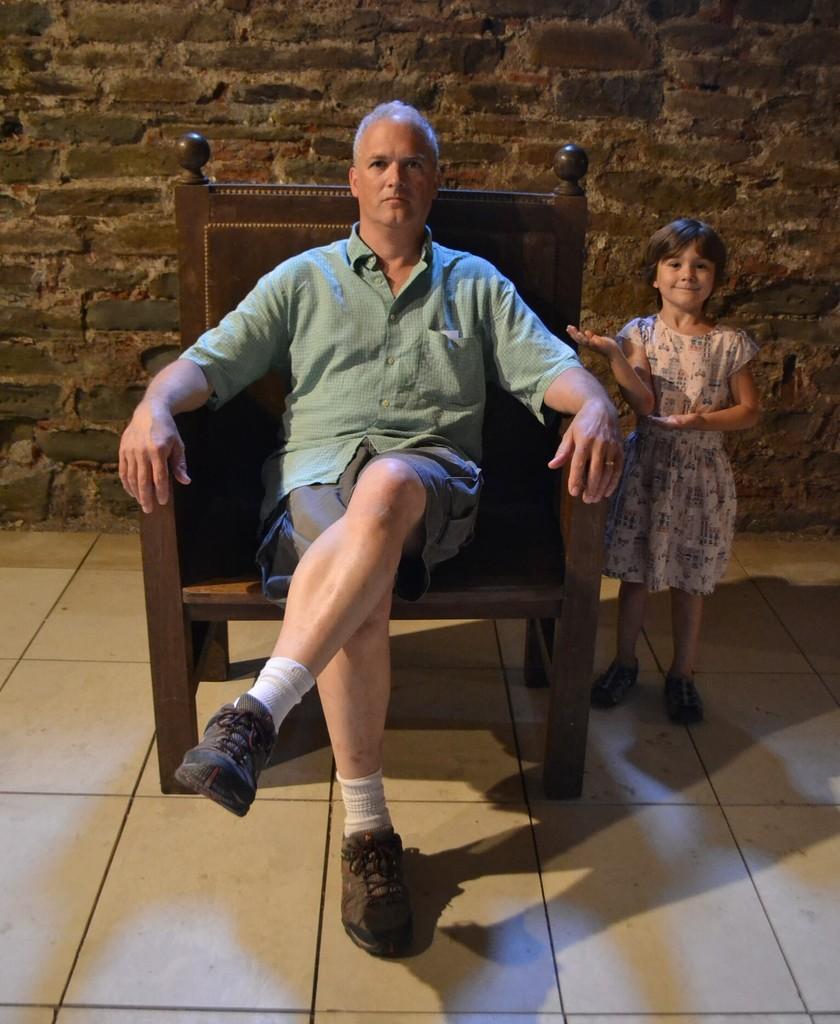Could you give a brief overview of what you see in this image? In this image i can see a man sitting on a chair at right i can see a girl standing, at the back ground there is a wall. 